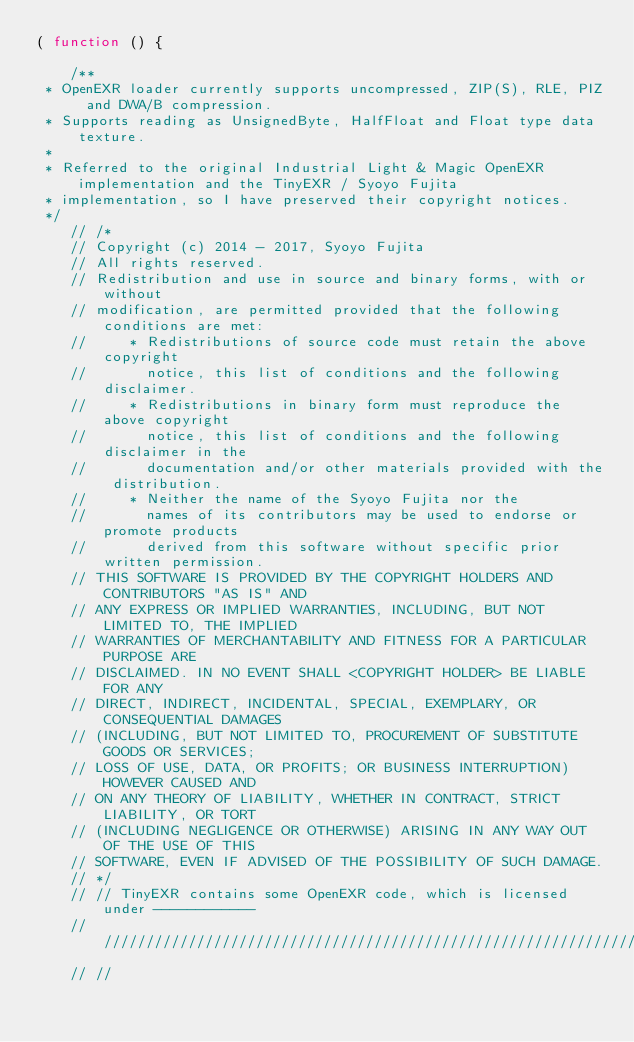Convert code to text. <code><loc_0><loc_0><loc_500><loc_500><_JavaScript_>( function () {

	/**
 * OpenEXR loader currently supports uncompressed, ZIP(S), RLE, PIZ and DWA/B compression.
 * Supports reading as UnsignedByte, HalfFloat and Float type data texture.
 *
 * Referred to the original Industrial Light & Magic OpenEXR implementation and the TinyEXR / Syoyo Fujita
 * implementation, so I have preserved their copyright notices.
 */
	// /*
	// Copyright (c) 2014 - 2017, Syoyo Fujita
	// All rights reserved.
	// Redistribution and use in source and binary forms, with or without
	// modification, are permitted provided that the following conditions are met:
	//     * Redistributions of source code must retain the above copyright
	//       notice, this list of conditions and the following disclaimer.
	//     * Redistributions in binary form must reproduce the above copyright
	//       notice, this list of conditions and the following disclaimer in the
	//       documentation and/or other materials provided with the distribution.
	//     * Neither the name of the Syoyo Fujita nor the
	//       names of its contributors may be used to endorse or promote products
	//       derived from this software without specific prior written permission.
	// THIS SOFTWARE IS PROVIDED BY THE COPYRIGHT HOLDERS AND CONTRIBUTORS "AS IS" AND
	// ANY EXPRESS OR IMPLIED WARRANTIES, INCLUDING, BUT NOT LIMITED TO, THE IMPLIED
	// WARRANTIES OF MERCHANTABILITY AND FITNESS FOR A PARTICULAR PURPOSE ARE
	// DISCLAIMED. IN NO EVENT SHALL <COPYRIGHT HOLDER> BE LIABLE FOR ANY
	// DIRECT, INDIRECT, INCIDENTAL, SPECIAL, EXEMPLARY, OR CONSEQUENTIAL DAMAGES
	// (INCLUDING, BUT NOT LIMITED TO, PROCUREMENT OF SUBSTITUTE GOODS OR SERVICES;
	// LOSS OF USE, DATA, OR PROFITS; OR BUSINESS INTERRUPTION) HOWEVER CAUSED AND
	// ON ANY THEORY OF LIABILITY, WHETHER IN CONTRACT, STRICT LIABILITY, OR TORT
	// (INCLUDING NEGLIGENCE OR OTHERWISE) ARISING IN ANY WAY OUT OF THE USE OF THIS
	// SOFTWARE, EVEN IF ADVISED OF THE POSSIBILITY OF SUCH DAMAGE.
	// */
	// // TinyEXR contains some OpenEXR code, which is licensed under ------------
	// ///////////////////////////////////////////////////////////////////////////
	// //</code> 